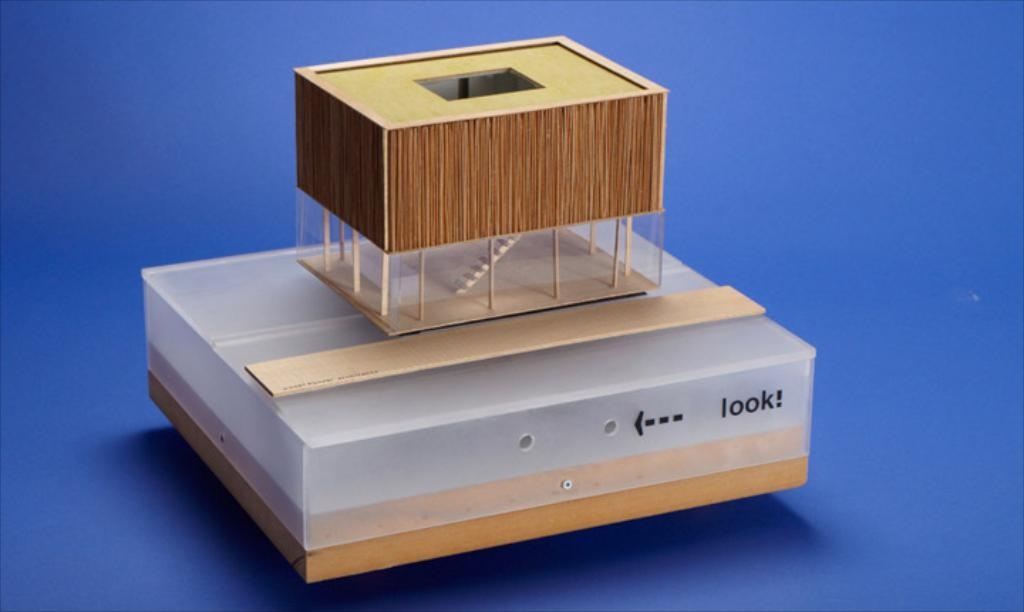<image>
Summarize the visual content of the image. a model of wood and plastic with a sign that reads LOOK! 